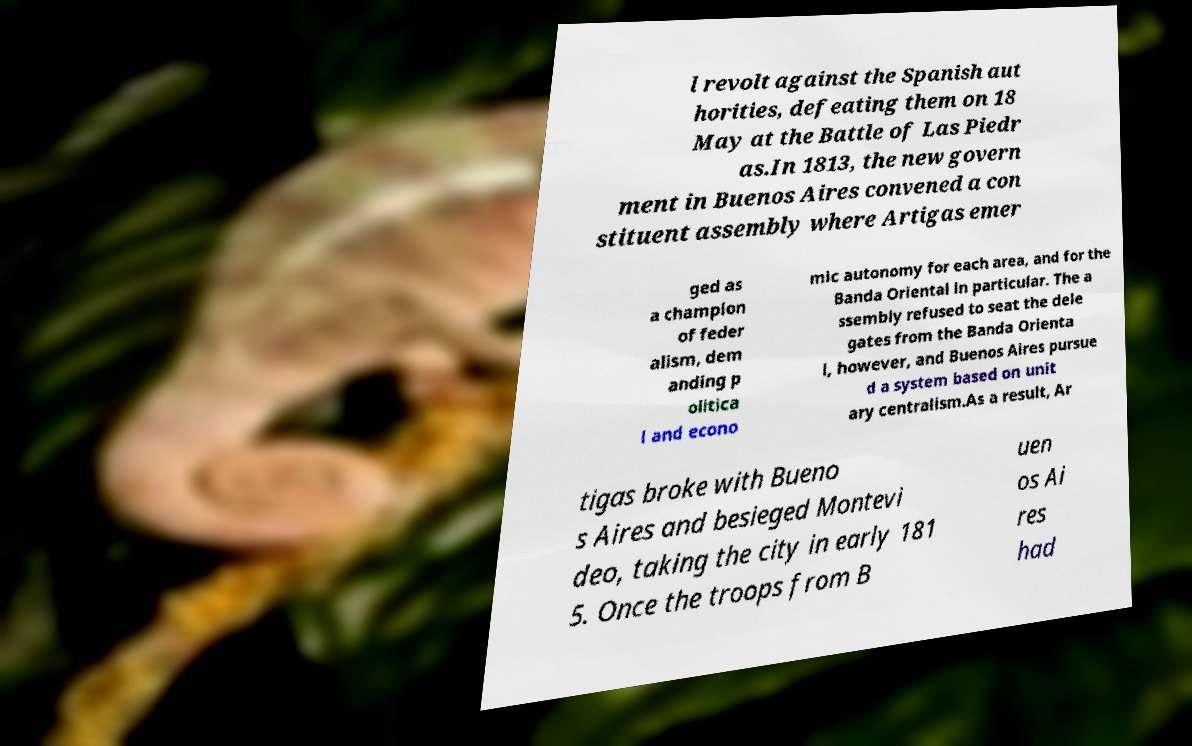Please read and relay the text visible in this image. What does it say? l revolt against the Spanish aut horities, defeating them on 18 May at the Battle of Las Piedr as.In 1813, the new govern ment in Buenos Aires convened a con stituent assembly where Artigas emer ged as a champion of feder alism, dem anding p olitica l and econo mic autonomy for each area, and for the Banda Oriental in particular. The a ssembly refused to seat the dele gates from the Banda Orienta l, however, and Buenos Aires pursue d a system based on unit ary centralism.As a result, Ar tigas broke with Bueno s Aires and besieged Montevi deo, taking the city in early 181 5. Once the troops from B uen os Ai res had 